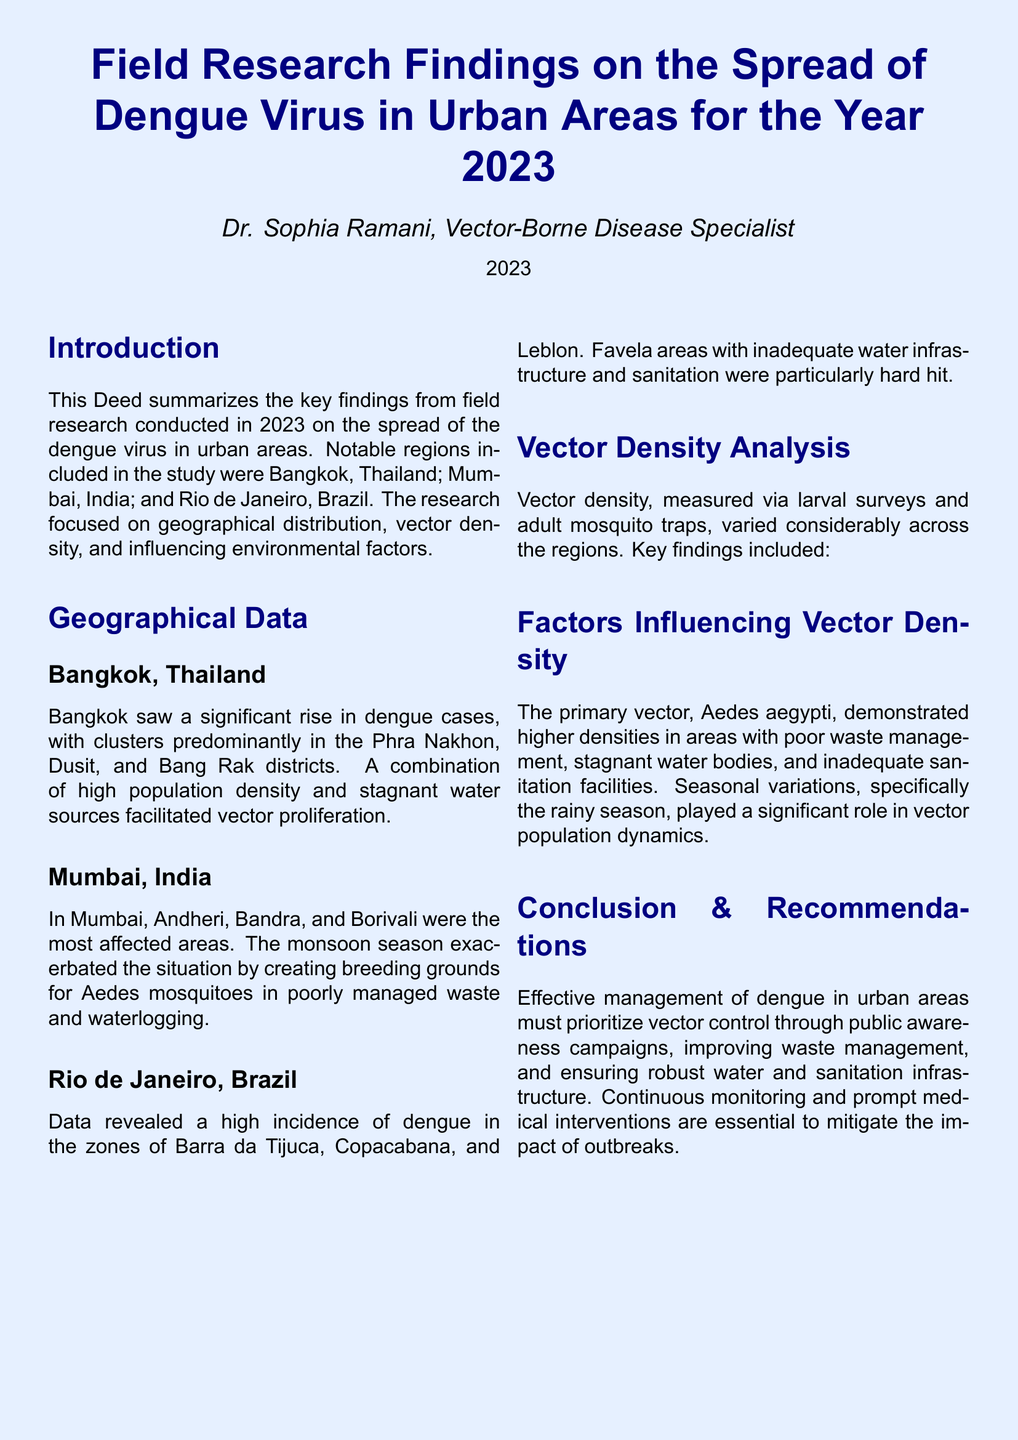what is the title of the document? The title is presented prominently at the beginning of the document.
Answer: Field Research Findings on the Spread of Dengue Virus in Urban Areas for the Year 2023 who conducted the research? The author's name is mentioned under the title as the specialist.
Answer: Dr. Sophia Ramani which district in Bangkok had significant dengue cases? The document lists specific districts affected by dengue in Bangkok.
Answer: Phra Nakhon, Dusit, and Bang Rak what contributing factor was noted for dengue spread in Mumbai? The document indicates specific environmental conditions that influence dengue spread in Mumbai.
Answer: Poorly managed waste and waterlogging what type of insect is primarily responsible for dengue transmission? The document specifies the primary vector responsible for transmitting the dengue virus.
Answer: Aedes aegypti which areas in Rio de Janeiro experienced a high incidence of dengue? The document mentions specific zones in Rio de Janeiro affected by dengue.
Answer: Barra da Tijuca, Copacabana, and Leblon what important season exacerbated dengue conditions in Mumbai? The document discusses seasonal factors affecting vector proliferation in Mumbai.
Answer: Monsoon season what is a primary recommendation for dengue management in urban areas? The conclusion section provides key recommendations for managing dengue outbreaks.
Answer: Vector control how was vector density measured in the research? The document describes the methods used to assess vector density throughout the study.
Answer: Larval surveys and adult mosquito traps 